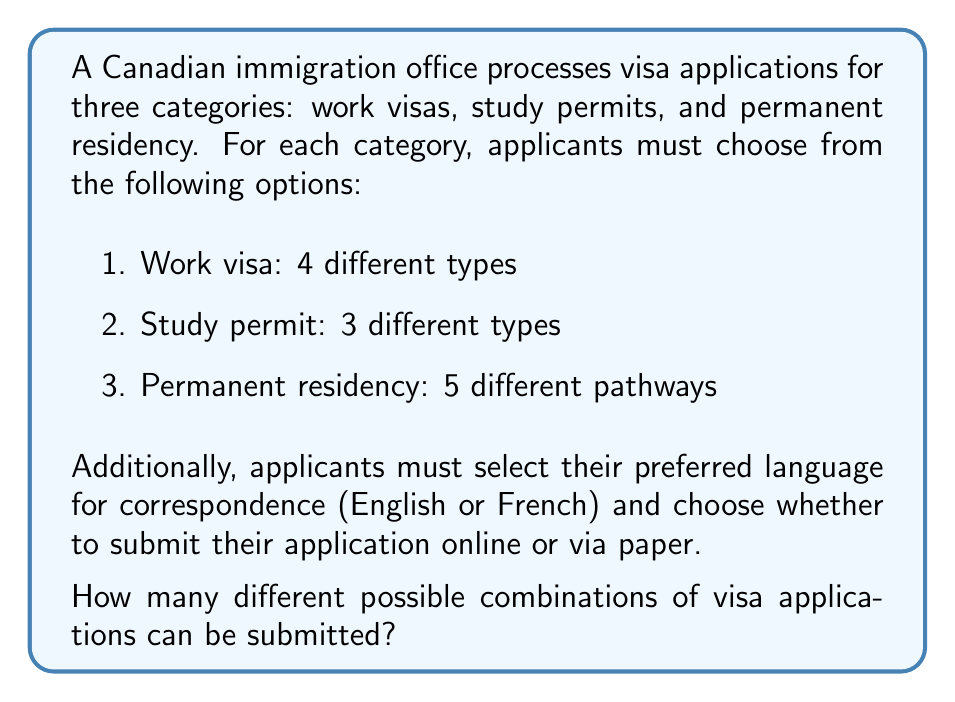Solve this math problem. To solve this problem, we'll use the multiplication principle of counting. We'll multiply the number of options for each choice to get the total number of possible combinations.

Let's break it down step by step:

1. Visa categories and types:
   - Work visa: 4 options
   - Study permit: 3 options
   - Permanent residency: 5 options
   Total visa options: $4 + 3 + 5 = 12$

2. Language options: 2 (English or French)

3. Submission method: 2 (online or paper)

Now, we multiply these options together:

$$ \text{Total combinations} = 12 \times 2 \times 2 $$

This can be calculated as:

$$ \text{Total combinations} = 12 \times 2 \times 2 = 48 $$

Therefore, there are 48 different possible combinations of visa applications that can be submitted.
Answer: 48 possible combinations 